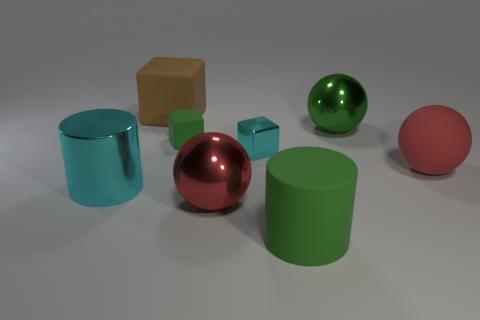Subtract all green cylinders. How many red balls are left? 2 Subtract all matte balls. How many balls are left? 2 Add 1 large balls. How many objects exist? 9 Subtract 1 spheres. How many spheres are left? 2 Subtract all gray spheres. Subtract all yellow cubes. How many spheres are left? 3 Subtract 0 red cylinders. How many objects are left? 8 Subtract all spheres. How many objects are left? 5 Subtract all tiny green things. Subtract all big gray things. How many objects are left? 7 Add 1 large green things. How many large green things are left? 3 Add 8 big red balls. How many big red balls exist? 10 